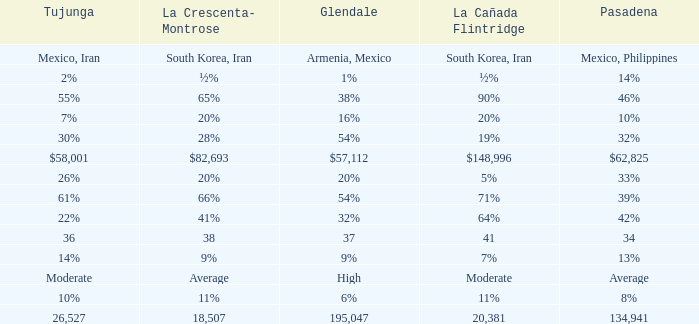Help me parse the entirety of this table. {'header': ['Tujunga', 'La Crescenta- Montrose', 'Glendale', 'La Cañada Flintridge', 'Pasadena'], 'rows': [['Mexico, Iran', 'South Korea, Iran', 'Armenia, Mexico', 'South Korea, Iran', 'Mexico, Philippines'], ['2%', '½%', '1%', '½%', '14%'], ['55%', '65%', '38%', '90%', '46%'], ['7%', '20%', '16%', '20%', '10%'], ['30%', '28%', '54%', '19%', '32%'], ['$58,001', '$82,693', '$57,112', '$148,996', '$62,825'], ['26%', '20%', '20%', '5%', '33%'], ['61%', '66%', '54%', '71%', '39%'], ['22%', '41%', '32%', '64%', '42%'], ['36', '38', '37', '41', '34'], ['14%', '9%', '9%', '7%', '13%'], ['Moderate', 'Average', 'High', 'Moderate', 'Average'], ['10%', '11%', '6%', '11%', '8%'], ['26,527', '18,507', '195,047', '20,381', '134,941']]} When La Crescenta-Montrose has 66%, what is Tujunga? 61%. 